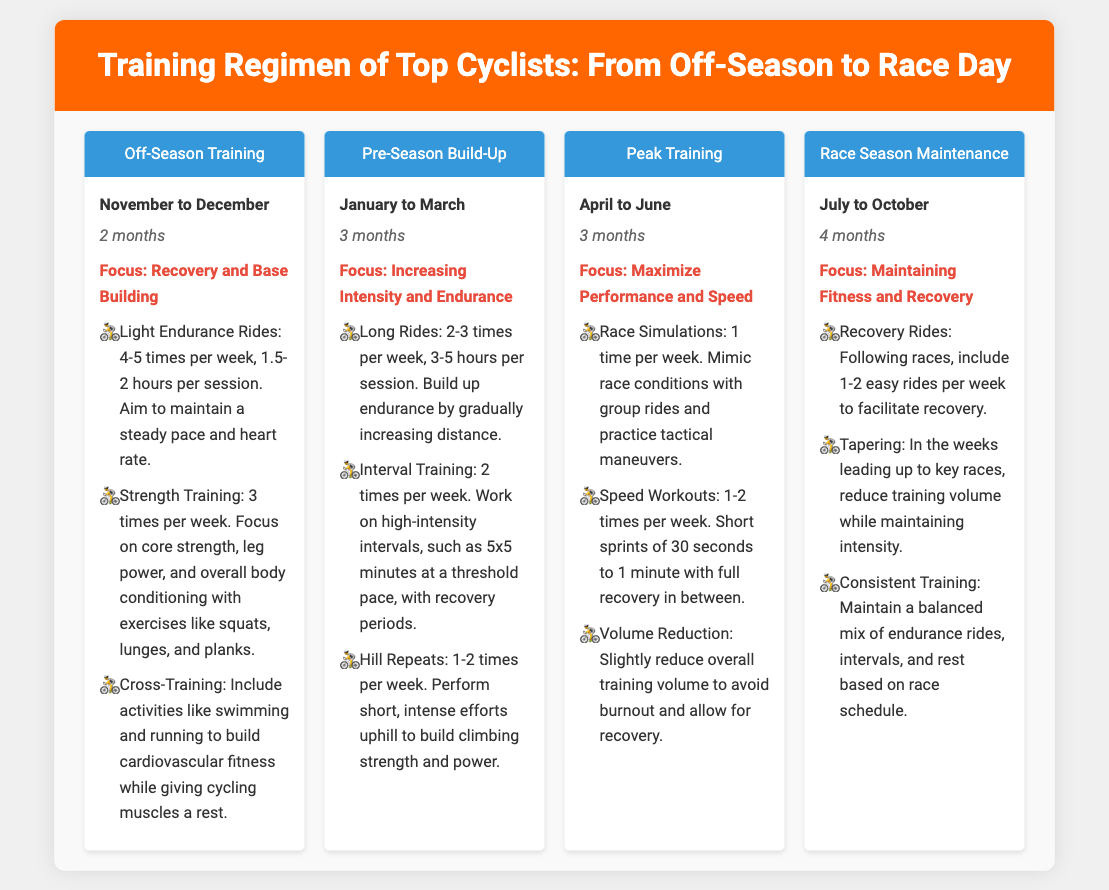What is the duration of the Off-Season Training phase? The Off-Season Training phase lasts for 2 months, from November to December.
Answer: 2 months What is the primary focus during the Peak Training phase? The focus during the Peak Training phase is to maximize performance and speed.
Answer: Maximize Performance and Speed How many times per week do cyclists perform strength training in the Off-Season? Cyclists perform strength training 3 times per week during the Off-Season.
Answer: 3 times What activities are included in the Pre-Season Build-Up phase? Activities include Long Rides, Interval Training, and Hill Repeats.
Answer: Long Rides, Interval Training, Hill Repeats How does training volume change during the weeks leading up to key races? The training volume is reduced while maintaining intensity during tapering.
Answer: Reduced What month does the Race Season Maintenance phase start? The Race Season Maintenance phase starts in July.
Answer: July During the Off-Season, how many easy rides are included for recovery after races? 1-2 easy rides per week are included for recovery.
Answer: 1-2 What is the duration of the Race Season Maintenance phase? The Race Season Maintenance phase lasts for 4 months, from July to October.
Answer: 4 months 